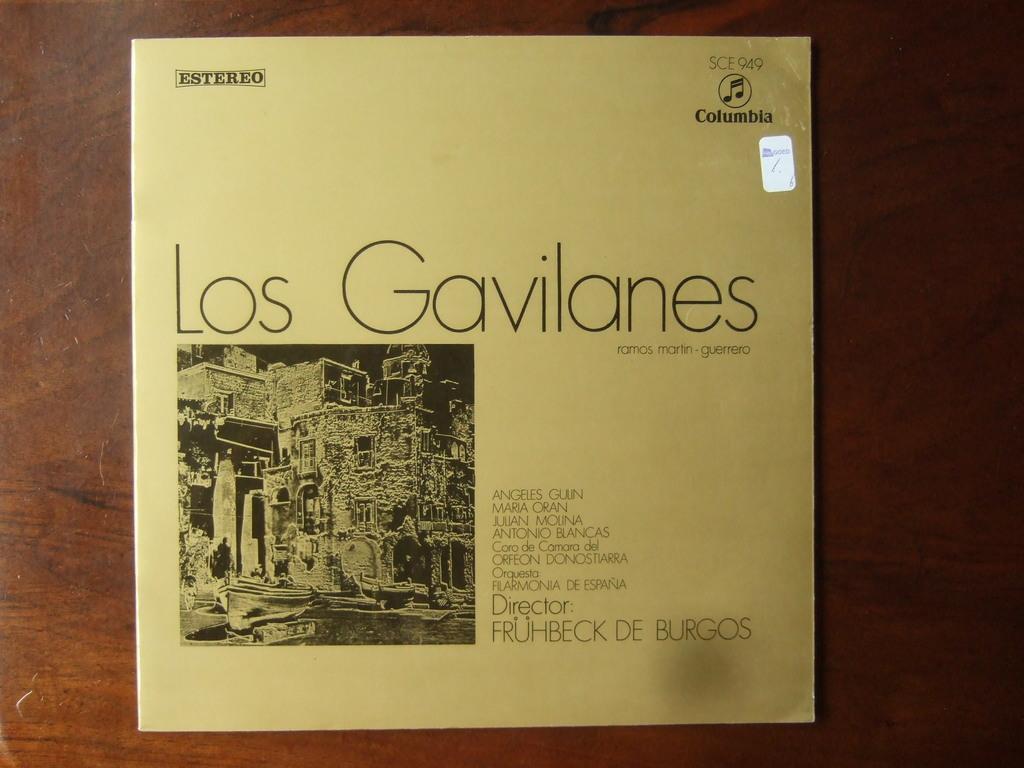Who is the director of this show?
Offer a terse response. Fruhbeck de burgos. What is the title?
Give a very brief answer. Los gavilanes. 